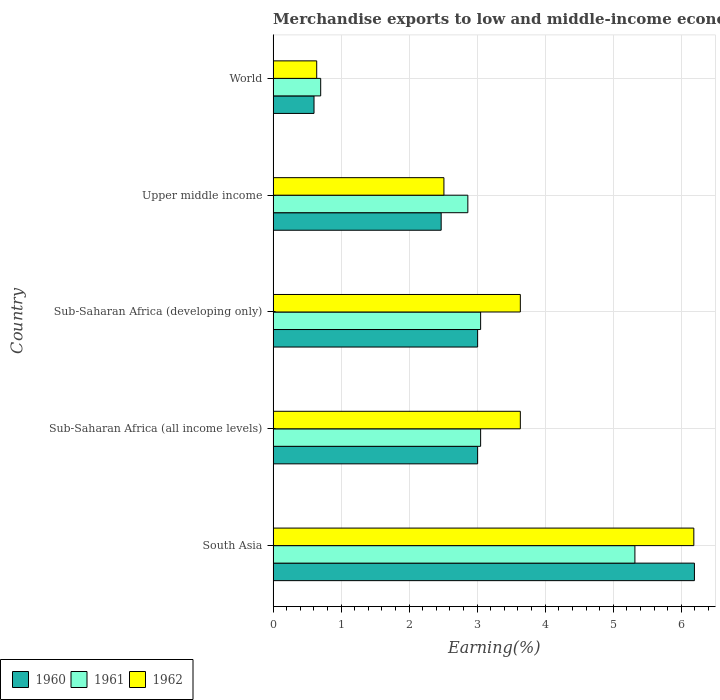How many different coloured bars are there?
Offer a terse response. 3. How many groups of bars are there?
Your response must be concise. 5. Are the number of bars per tick equal to the number of legend labels?
Your response must be concise. Yes. How many bars are there on the 4th tick from the bottom?
Make the answer very short. 3. What is the percentage of amount earned from merchandise exports in 1960 in Upper middle income?
Make the answer very short. 2.47. Across all countries, what is the maximum percentage of amount earned from merchandise exports in 1960?
Your answer should be compact. 6.19. Across all countries, what is the minimum percentage of amount earned from merchandise exports in 1960?
Provide a short and direct response. 0.6. In which country was the percentage of amount earned from merchandise exports in 1960 maximum?
Your answer should be compact. South Asia. In which country was the percentage of amount earned from merchandise exports in 1962 minimum?
Make the answer very short. World. What is the total percentage of amount earned from merchandise exports in 1961 in the graph?
Your answer should be compact. 14.98. What is the difference between the percentage of amount earned from merchandise exports in 1962 in South Asia and that in Sub-Saharan Africa (all income levels)?
Provide a succinct answer. 2.55. What is the difference between the percentage of amount earned from merchandise exports in 1960 in South Asia and the percentage of amount earned from merchandise exports in 1961 in World?
Your response must be concise. 5.49. What is the average percentage of amount earned from merchandise exports in 1960 per country?
Keep it short and to the point. 3.06. What is the difference between the percentage of amount earned from merchandise exports in 1961 and percentage of amount earned from merchandise exports in 1960 in Sub-Saharan Africa (developing only)?
Your answer should be compact. 0.04. In how many countries, is the percentage of amount earned from merchandise exports in 1961 greater than 2.8 %?
Ensure brevity in your answer.  4. What is the ratio of the percentage of amount earned from merchandise exports in 1960 in South Asia to that in World?
Make the answer very short. 10.3. What is the difference between the highest and the second highest percentage of amount earned from merchandise exports in 1961?
Make the answer very short. 2.27. What is the difference between the highest and the lowest percentage of amount earned from merchandise exports in 1960?
Make the answer very short. 5.59. What does the 3rd bar from the top in Upper middle income represents?
Your response must be concise. 1960. How many bars are there?
Keep it short and to the point. 15. Are the values on the major ticks of X-axis written in scientific E-notation?
Keep it short and to the point. No. Does the graph contain any zero values?
Offer a very short reply. No. Where does the legend appear in the graph?
Your answer should be compact. Bottom left. How many legend labels are there?
Provide a short and direct response. 3. How are the legend labels stacked?
Ensure brevity in your answer.  Horizontal. What is the title of the graph?
Offer a very short reply. Merchandise exports to low and middle-income economies within region. What is the label or title of the X-axis?
Make the answer very short. Earning(%). What is the label or title of the Y-axis?
Ensure brevity in your answer.  Country. What is the Earning(%) of 1960 in South Asia?
Your answer should be very brief. 6.19. What is the Earning(%) of 1961 in South Asia?
Offer a very short reply. 5.32. What is the Earning(%) of 1962 in South Asia?
Give a very brief answer. 6.19. What is the Earning(%) in 1960 in Sub-Saharan Africa (all income levels)?
Keep it short and to the point. 3.01. What is the Earning(%) of 1961 in Sub-Saharan Africa (all income levels)?
Offer a terse response. 3.05. What is the Earning(%) in 1962 in Sub-Saharan Africa (all income levels)?
Offer a very short reply. 3.63. What is the Earning(%) in 1960 in Sub-Saharan Africa (developing only)?
Keep it short and to the point. 3.01. What is the Earning(%) in 1961 in Sub-Saharan Africa (developing only)?
Your answer should be very brief. 3.05. What is the Earning(%) in 1962 in Sub-Saharan Africa (developing only)?
Your answer should be very brief. 3.63. What is the Earning(%) of 1960 in Upper middle income?
Give a very brief answer. 2.47. What is the Earning(%) of 1961 in Upper middle income?
Your response must be concise. 2.86. What is the Earning(%) in 1962 in Upper middle income?
Your answer should be compact. 2.51. What is the Earning(%) in 1960 in World?
Your response must be concise. 0.6. What is the Earning(%) of 1961 in World?
Your answer should be compact. 0.7. What is the Earning(%) of 1962 in World?
Make the answer very short. 0.64. Across all countries, what is the maximum Earning(%) in 1960?
Offer a very short reply. 6.19. Across all countries, what is the maximum Earning(%) in 1961?
Your answer should be very brief. 5.32. Across all countries, what is the maximum Earning(%) in 1962?
Offer a terse response. 6.19. Across all countries, what is the minimum Earning(%) in 1960?
Offer a very short reply. 0.6. Across all countries, what is the minimum Earning(%) in 1961?
Provide a short and direct response. 0.7. Across all countries, what is the minimum Earning(%) in 1962?
Provide a succinct answer. 0.64. What is the total Earning(%) in 1960 in the graph?
Offer a very short reply. 15.28. What is the total Earning(%) of 1961 in the graph?
Your response must be concise. 14.98. What is the total Earning(%) of 1962 in the graph?
Your answer should be very brief. 16.61. What is the difference between the Earning(%) of 1960 in South Asia and that in Sub-Saharan Africa (all income levels)?
Offer a terse response. 3.19. What is the difference between the Earning(%) in 1961 in South Asia and that in Sub-Saharan Africa (all income levels)?
Keep it short and to the point. 2.27. What is the difference between the Earning(%) in 1962 in South Asia and that in Sub-Saharan Africa (all income levels)?
Ensure brevity in your answer.  2.55. What is the difference between the Earning(%) of 1960 in South Asia and that in Sub-Saharan Africa (developing only)?
Your answer should be very brief. 3.19. What is the difference between the Earning(%) in 1961 in South Asia and that in Sub-Saharan Africa (developing only)?
Provide a succinct answer. 2.27. What is the difference between the Earning(%) in 1962 in South Asia and that in Sub-Saharan Africa (developing only)?
Keep it short and to the point. 2.55. What is the difference between the Earning(%) of 1960 in South Asia and that in Upper middle income?
Provide a succinct answer. 3.72. What is the difference between the Earning(%) of 1961 in South Asia and that in Upper middle income?
Your answer should be very brief. 2.46. What is the difference between the Earning(%) of 1962 in South Asia and that in Upper middle income?
Give a very brief answer. 3.67. What is the difference between the Earning(%) in 1960 in South Asia and that in World?
Give a very brief answer. 5.59. What is the difference between the Earning(%) in 1961 in South Asia and that in World?
Provide a succinct answer. 4.62. What is the difference between the Earning(%) in 1962 in South Asia and that in World?
Provide a succinct answer. 5.54. What is the difference between the Earning(%) of 1960 in Sub-Saharan Africa (all income levels) and that in Sub-Saharan Africa (developing only)?
Your response must be concise. 0. What is the difference between the Earning(%) of 1960 in Sub-Saharan Africa (all income levels) and that in Upper middle income?
Offer a very short reply. 0.54. What is the difference between the Earning(%) of 1961 in Sub-Saharan Africa (all income levels) and that in Upper middle income?
Provide a short and direct response. 0.19. What is the difference between the Earning(%) of 1962 in Sub-Saharan Africa (all income levels) and that in Upper middle income?
Keep it short and to the point. 1.12. What is the difference between the Earning(%) of 1960 in Sub-Saharan Africa (all income levels) and that in World?
Provide a short and direct response. 2.41. What is the difference between the Earning(%) of 1961 in Sub-Saharan Africa (all income levels) and that in World?
Offer a terse response. 2.35. What is the difference between the Earning(%) in 1962 in Sub-Saharan Africa (all income levels) and that in World?
Your response must be concise. 2.99. What is the difference between the Earning(%) of 1960 in Sub-Saharan Africa (developing only) and that in Upper middle income?
Provide a succinct answer. 0.54. What is the difference between the Earning(%) of 1961 in Sub-Saharan Africa (developing only) and that in Upper middle income?
Offer a terse response. 0.19. What is the difference between the Earning(%) of 1962 in Sub-Saharan Africa (developing only) and that in Upper middle income?
Make the answer very short. 1.12. What is the difference between the Earning(%) of 1960 in Sub-Saharan Africa (developing only) and that in World?
Offer a very short reply. 2.41. What is the difference between the Earning(%) in 1961 in Sub-Saharan Africa (developing only) and that in World?
Your answer should be compact. 2.35. What is the difference between the Earning(%) in 1962 in Sub-Saharan Africa (developing only) and that in World?
Your answer should be very brief. 2.99. What is the difference between the Earning(%) in 1960 in Upper middle income and that in World?
Provide a succinct answer. 1.87. What is the difference between the Earning(%) in 1961 in Upper middle income and that in World?
Your answer should be very brief. 2.16. What is the difference between the Earning(%) in 1962 in Upper middle income and that in World?
Offer a very short reply. 1.87. What is the difference between the Earning(%) of 1960 in South Asia and the Earning(%) of 1961 in Sub-Saharan Africa (all income levels)?
Your answer should be compact. 3.14. What is the difference between the Earning(%) of 1960 in South Asia and the Earning(%) of 1962 in Sub-Saharan Africa (all income levels)?
Your answer should be very brief. 2.56. What is the difference between the Earning(%) in 1961 in South Asia and the Earning(%) in 1962 in Sub-Saharan Africa (all income levels)?
Your response must be concise. 1.68. What is the difference between the Earning(%) in 1960 in South Asia and the Earning(%) in 1961 in Sub-Saharan Africa (developing only)?
Your answer should be compact. 3.14. What is the difference between the Earning(%) in 1960 in South Asia and the Earning(%) in 1962 in Sub-Saharan Africa (developing only)?
Ensure brevity in your answer.  2.56. What is the difference between the Earning(%) in 1961 in South Asia and the Earning(%) in 1962 in Sub-Saharan Africa (developing only)?
Make the answer very short. 1.68. What is the difference between the Earning(%) in 1960 in South Asia and the Earning(%) in 1961 in Upper middle income?
Your answer should be compact. 3.33. What is the difference between the Earning(%) in 1960 in South Asia and the Earning(%) in 1962 in Upper middle income?
Your answer should be compact. 3.68. What is the difference between the Earning(%) in 1961 in South Asia and the Earning(%) in 1962 in Upper middle income?
Keep it short and to the point. 2.81. What is the difference between the Earning(%) of 1960 in South Asia and the Earning(%) of 1961 in World?
Your response must be concise. 5.49. What is the difference between the Earning(%) of 1960 in South Asia and the Earning(%) of 1962 in World?
Provide a succinct answer. 5.55. What is the difference between the Earning(%) in 1961 in South Asia and the Earning(%) in 1962 in World?
Your answer should be compact. 4.68. What is the difference between the Earning(%) in 1960 in Sub-Saharan Africa (all income levels) and the Earning(%) in 1961 in Sub-Saharan Africa (developing only)?
Offer a very short reply. -0.04. What is the difference between the Earning(%) of 1960 in Sub-Saharan Africa (all income levels) and the Earning(%) of 1962 in Sub-Saharan Africa (developing only)?
Keep it short and to the point. -0.63. What is the difference between the Earning(%) of 1961 in Sub-Saharan Africa (all income levels) and the Earning(%) of 1962 in Sub-Saharan Africa (developing only)?
Provide a short and direct response. -0.58. What is the difference between the Earning(%) in 1960 in Sub-Saharan Africa (all income levels) and the Earning(%) in 1961 in Upper middle income?
Your answer should be compact. 0.14. What is the difference between the Earning(%) in 1960 in Sub-Saharan Africa (all income levels) and the Earning(%) in 1962 in Upper middle income?
Keep it short and to the point. 0.5. What is the difference between the Earning(%) of 1961 in Sub-Saharan Africa (all income levels) and the Earning(%) of 1962 in Upper middle income?
Your answer should be very brief. 0.54. What is the difference between the Earning(%) in 1960 in Sub-Saharan Africa (all income levels) and the Earning(%) in 1961 in World?
Offer a terse response. 2.31. What is the difference between the Earning(%) in 1960 in Sub-Saharan Africa (all income levels) and the Earning(%) in 1962 in World?
Ensure brevity in your answer.  2.37. What is the difference between the Earning(%) of 1961 in Sub-Saharan Africa (all income levels) and the Earning(%) of 1962 in World?
Your answer should be very brief. 2.41. What is the difference between the Earning(%) of 1960 in Sub-Saharan Africa (developing only) and the Earning(%) of 1961 in Upper middle income?
Offer a very short reply. 0.14. What is the difference between the Earning(%) of 1960 in Sub-Saharan Africa (developing only) and the Earning(%) of 1962 in Upper middle income?
Offer a very short reply. 0.5. What is the difference between the Earning(%) in 1961 in Sub-Saharan Africa (developing only) and the Earning(%) in 1962 in Upper middle income?
Offer a terse response. 0.54. What is the difference between the Earning(%) of 1960 in Sub-Saharan Africa (developing only) and the Earning(%) of 1961 in World?
Your answer should be very brief. 2.31. What is the difference between the Earning(%) in 1960 in Sub-Saharan Africa (developing only) and the Earning(%) in 1962 in World?
Keep it short and to the point. 2.37. What is the difference between the Earning(%) in 1961 in Sub-Saharan Africa (developing only) and the Earning(%) in 1962 in World?
Ensure brevity in your answer.  2.41. What is the difference between the Earning(%) in 1960 in Upper middle income and the Earning(%) in 1961 in World?
Your response must be concise. 1.77. What is the difference between the Earning(%) of 1960 in Upper middle income and the Earning(%) of 1962 in World?
Give a very brief answer. 1.83. What is the difference between the Earning(%) in 1961 in Upper middle income and the Earning(%) in 1962 in World?
Your answer should be very brief. 2.22. What is the average Earning(%) of 1960 per country?
Provide a succinct answer. 3.06. What is the average Earning(%) of 1961 per country?
Keep it short and to the point. 3. What is the average Earning(%) of 1962 per country?
Your response must be concise. 3.32. What is the difference between the Earning(%) in 1960 and Earning(%) in 1961 in South Asia?
Provide a short and direct response. 0.88. What is the difference between the Earning(%) of 1960 and Earning(%) of 1962 in South Asia?
Provide a succinct answer. 0.01. What is the difference between the Earning(%) of 1961 and Earning(%) of 1962 in South Asia?
Keep it short and to the point. -0.87. What is the difference between the Earning(%) of 1960 and Earning(%) of 1961 in Sub-Saharan Africa (all income levels)?
Keep it short and to the point. -0.04. What is the difference between the Earning(%) in 1960 and Earning(%) in 1962 in Sub-Saharan Africa (all income levels)?
Provide a short and direct response. -0.63. What is the difference between the Earning(%) in 1961 and Earning(%) in 1962 in Sub-Saharan Africa (all income levels)?
Make the answer very short. -0.58. What is the difference between the Earning(%) in 1960 and Earning(%) in 1961 in Sub-Saharan Africa (developing only)?
Ensure brevity in your answer.  -0.04. What is the difference between the Earning(%) of 1960 and Earning(%) of 1962 in Sub-Saharan Africa (developing only)?
Provide a succinct answer. -0.63. What is the difference between the Earning(%) of 1961 and Earning(%) of 1962 in Sub-Saharan Africa (developing only)?
Your answer should be compact. -0.58. What is the difference between the Earning(%) in 1960 and Earning(%) in 1961 in Upper middle income?
Provide a short and direct response. -0.39. What is the difference between the Earning(%) of 1960 and Earning(%) of 1962 in Upper middle income?
Offer a terse response. -0.04. What is the difference between the Earning(%) of 1961 and Earning(%) of 1962 in Upper middle income?
Your answer should be very brief. 0.35. What is the difference between the Earning(%) in 1960 and Earning(%) in 1961 in World?
Provide a succinct answer. -0.1. What is the difference between the Earning(%) of 1960 and Earning(%) of 1962 in World?
Your response must be concise. -0.04. What is the difference between the Earning(%) in 1961 and Earning(%) in 1962 in World?
Your answer should be very brief. 0.06. What is the ratio of the Earning(%) in 1960 in South Asia to that in Sub-Saharan Africa (all income levels)?
Provide a succinct answer. 2.06. What is the ratio of the Earning(%) in 1961 in South Asia to that in Sub-Saharan Africa (all income levels)?
Provide a succinct answer. 1.74. What is the ratio of the Earning(%) in 1962 in South Asia to that in Sub-Saharan Africa (all income levels)?
Your answer should be very brief. 1.7. What is the ratio of the Earning(%) in 1960 in South Asia to that in Sub-Saharan Africa (developing only)?
Make the answer very short. 2.06. What is the ratio of the Earning(%) of 1961 in South Asia to that in Sub-Saharan Africa (developing only)?
Your answer should be compact. 1.74. What is the ratio of the Earning(%) of 1962 in South Asia to that in Sub-Saharan Africa (developing only)?
Ensure brevity in your answer.  1.7. What is the ratio of the Earning(%) of 1960 in South Asia to that in Upper middle income?
Ensure brevity in your answer.  2.51. What is the ratio of the Earning(%) of 1961 in South Asia to that in Upper middle income?
Ensure brevity in your answer.  1.86. What is the ratio of the Earning(%) in 1962 in South Asia to that in Upper middle income?
Offer a very short reply. 2.46. What is the ratio of the Earning(%) in 1960 in South Asia to that in World?
Ensure brevity in your answer.  10.3. What is the ratio of the Earning(%) of 1961 in South Asia to that in World?
Provide a short and direct response. 7.61. What is the ratio of the Earning(%) in 1962 in South Asia to that in World?
Your response must be concise. 9.65. What is the ratio of the Earning(%) of 1960 in Sub-Saharan Africa (all income levels) to that in Sub-Saharan Africa (developing only)?
Ensure brevity in your answer.  1. What is the ratio of the Earning(%) in 1960 in Sub-Saharan Africa (all income levels) to that in Upper middle income?
Provide a short and direct response. 1.22. What is the ratio of the Earning(%) in 1961 in Sub-Saharan Africa (all income levels) to that in Upper middle income?
Offer a terse response. 1.07. What is the ratio of the Earning(%) of 1962 in Sub-Saharan Africa (all income levels) to that in Upper middle income?
Provide a succinct answer. 1.45. What is the ratio of the Earning(%) of 1960 in Sub-Saharan Africa (all income levels) to that in World?
Your response must be concise. 5. What is the ratio of the Earning(%) of 1961 in Sub-Saharan Africa (all income levels) to that in World?
Give a very brief answer. 4.36. What is the ratio of the Earning(%) of 1962 in Sub-Saharan Africa (all income levels) to that in World?
Make the answer very short. 5.67. What is the ratio of the Earning(%) in 1960 in Sub-Saharan Africa (developing only) to that in Upper middle income?
Your response must be concise. 1.22. What is the ratio of the Earning(%) of 1961 in Sub-Saharan Africa (developing only) to that in Upper middle income?
Your answer should be compact. 1.07. What is the ratio of the Earning(%) in 1962 in Sub-Saharan Africa (developing only) to that in Upper middle income?
Make the answer very short. 1.45. What is the ratio of the Earning(%) of 1960 in Sub-Saharan Africa (developing only) to that in World?
Give a very brief answer. 5. What is the ratio of the Earning(%) of 1961 in Sub-Saharan Africa (developing only) to that in World?
Give a very brief answer. 4.36. What is the ratio of the Earning(%) of 1962 in Sub-Saharan Africa (developing only) to that in World?
Provide a succinct answer. 5.67. What is the ratio of the Earning(%) of 1960 in Upper middle income to that in World?
Offer a terse response. 4.11. What is the ratio of the Earning(%) of 1961 in Upper middle income to that in World?
Make the answer very short. 4.09. What is the ratio of the Earning(%) of 1962 in Upper middle income to that in World?
Provide a short and direct response. 3.92. What is the difference between the highest and the second highest Earning(%) of 1960?
Make the answer very short. 3.19. What is the difference between the highest and the second highest Earning(%) in 1961?
Make the answer very short. 2.27. What is the difference between the highest and the second highest Earning(%) in 1962?
Ensure brevity in your answer.  2.55. What is the difference between the highest and the lowest Earning(%) in 1960?
Provide a short and direct response. 5.59. What is the difference between the highest and the lowest Earning(%) in 1961?
Your answer should be compact. 4.62. What is the difference between the highest and the lowest Earning(%) of 1962?
Keep it short and to the point. 5.54. 